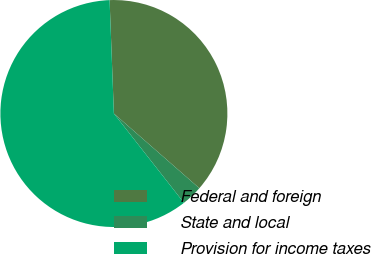<chart> <loc_0><loc_0><loc_500><loc_500><pie_chart><fcel>Federal and foreign<fcel>State and local<fcel>Provision for income taxes<nl><fcel>37.03%<fcel>2.98%<fcel>59.98%<nl></chart> 